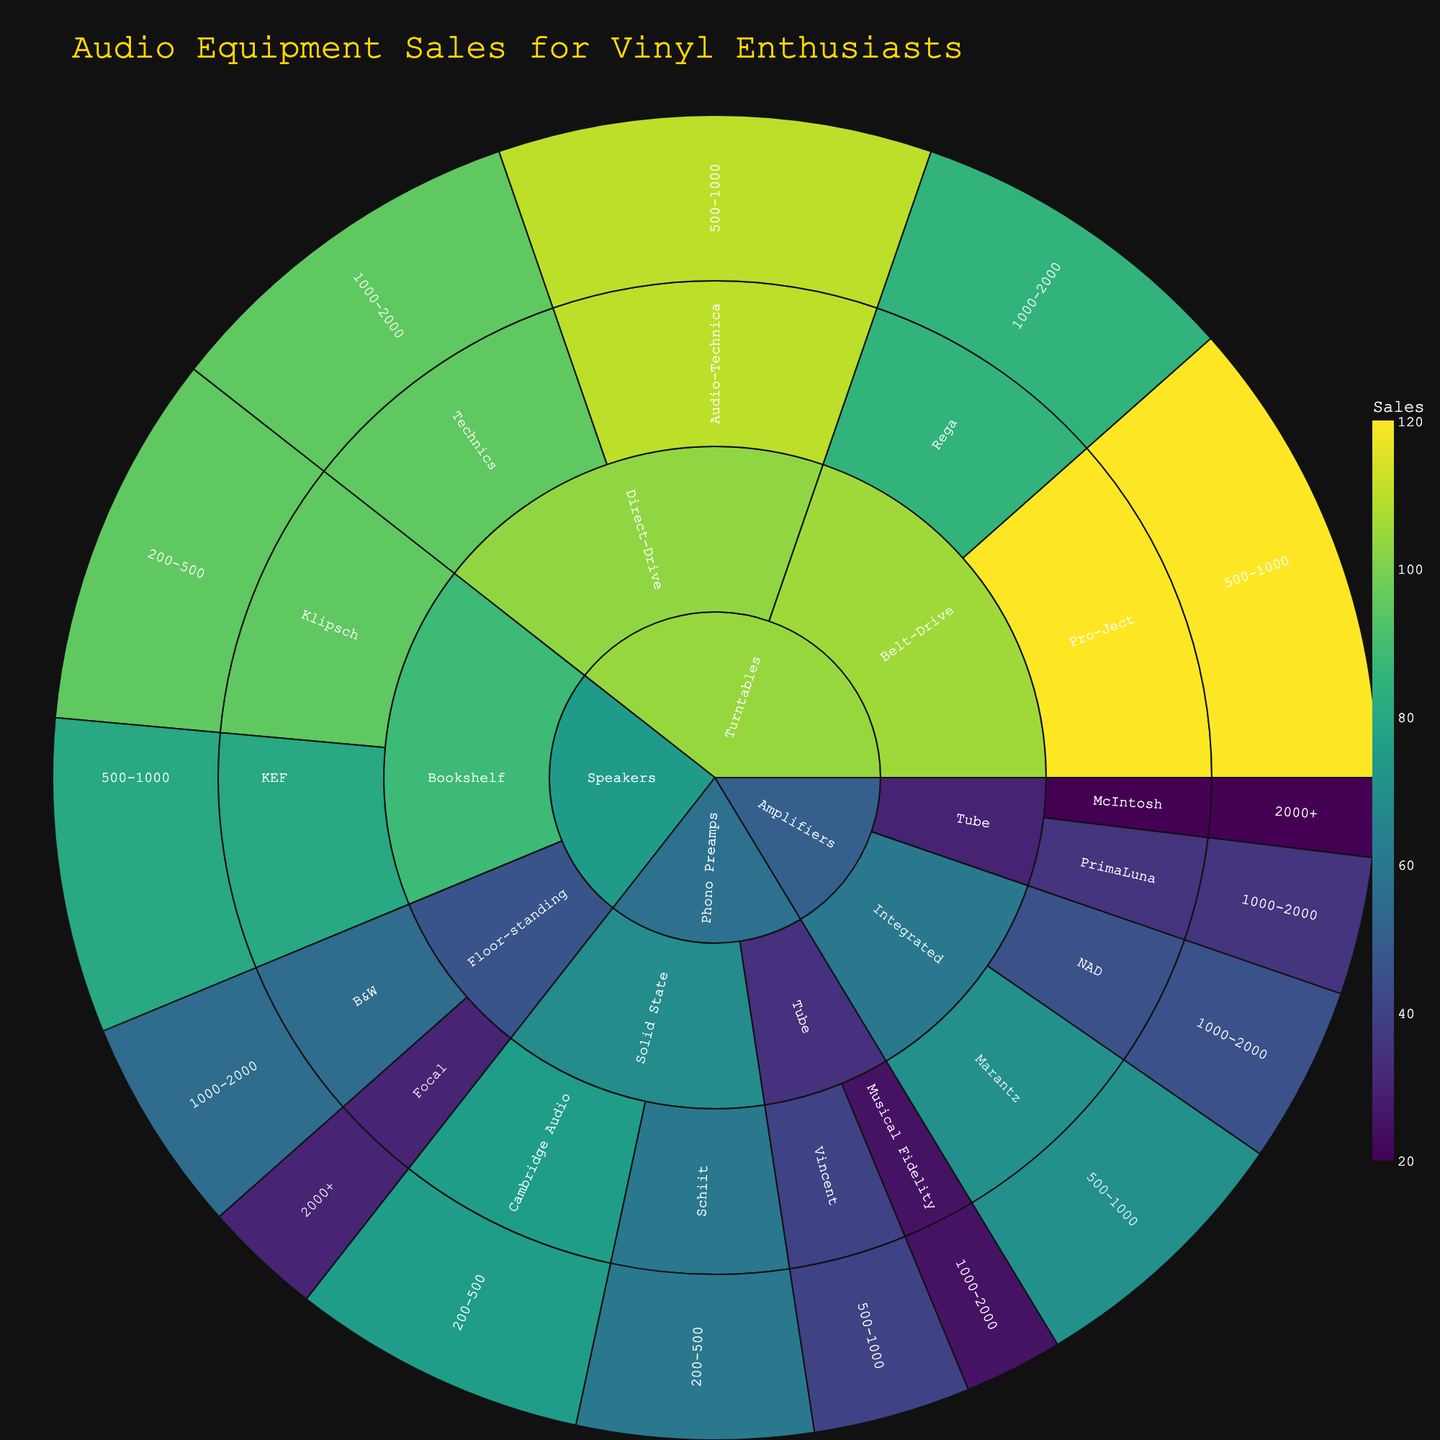What is the total number of sales for Belt-Drive Turntables? Look at the labels under Turntables and sum the sales for Belt-Drive types which include Pro-Ject (120) and Rega (85). Total sales = 120 + 85.
Answer: 205 Which category has the highest total sales? Sum the sales for each major category. Turntables = 120+85+95+110, Phono Preamps = 40+25+75+60, Speakers = 80+95+30+55, Amplifiers = 70+45+20+35. The categories have the total sales as 410, 200, 260, and 170 respectively.
Answer: Turntables What is the sales difference between Cambridge Audio and Schiit phono preamps? Directly compare the sales figures: Cambridge Audio has 75 and Schiit has 60. Difference = 75 - 60.
Answer: 15 Which brand has the highest sales within the Bookshelf Speakers type? Look at the sales figures under Speakers > Bookshelf and compare KEF (80) and Klipsch (95).
Answer: Klipsch What's the combined sales value for speakers priced over $1000? Sum the sales for speakers in price ranges $1000-2000 and $2000+. B&W has 55 and Focal has 30. Total = 55 + 30.
Answer: 85 What is the price range with the highest sales for Turntables? Compare the Turntables' sales across different price ranges. 500-1000 (Pro-Ject 120 + Audio-Technica 110 = 230) and 1000-2000 (Rega 85 + Technics 95 = 180).
Answer: 500-1000 Which type of Phono Preamps has higher total sales and by how much? Sum the sales for each type under Phono Preamps. Tube: Vincent (40) + Musical Fidelity (25) = 65; Solid State: Cambridge Audio (75) + Schiit (60) = 135. Difference = 135 - 65.
Answer: Solid State, by 70 What's the average sales for amplifiers priced 500-1000? Consider only the sales numbers in that price range for amplifiers: Marantz has 70.
Answer: 70 Which amplifier type has more sales, Integrated or Tube, and what’s the difference? Sum the sales for each amplifier type. Integrated = Marantz (70) + NAD (45) = 115; Tube = McIntosh (20) + PrimaLuna (35) = 55. Difference = 115 - 55.
Answer: Integrated, by 60 Which brand has the lowest overall sales across all categories and types? Compare the totals for each brand by summing their sales across all categories. Vincent (40), Musical Fidelity (25), Schiit (60), Cambridge Audio (75), McIntosh (20), PrimaLuna (35). The lowest is Musical Fidelity.
Answer: Musical Fidelity 